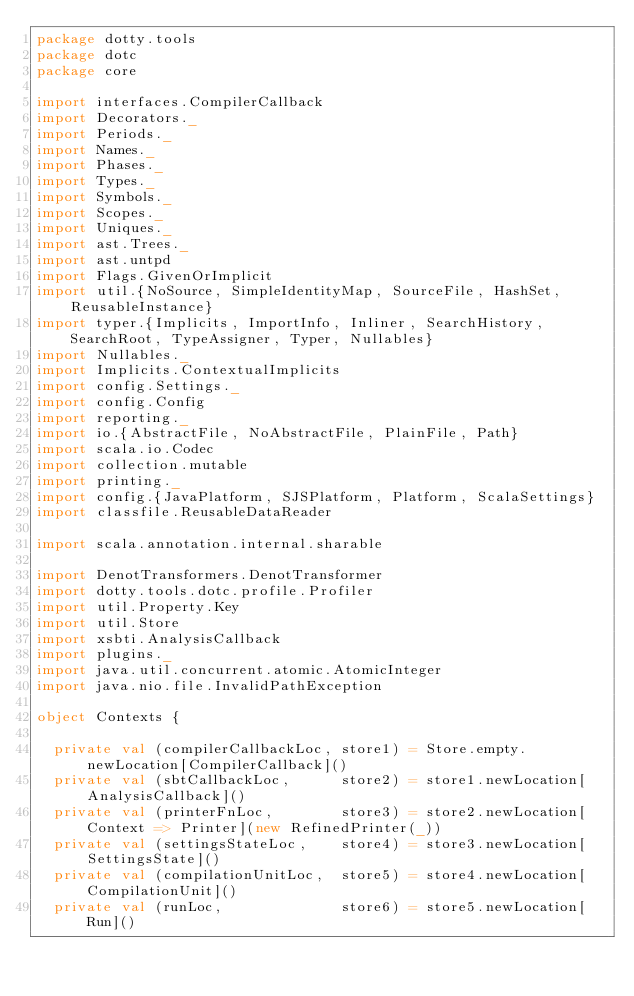Convert code to text. <code><loc_0><loc_0><loc_500><loc_500><_Scala_>package dotty.tools
package dotc
package core

import interfaces.CompilerCallback
import Decorators._
import Periods._
import Names._
import Phases._
import Types._
import Symbols._
import Scopes._
import Uniques._
import ast.Trees._
import ast.untpd
import Flags.GivenOrImplicit
import util.{NoSource, SimpleIdentityMap, SourceFile, HashSet, ReusableInstance}
import typer.{Implicits, ImportInfo, Inliner, SearchHistory, SearchRoot, TypeAssigner, Typer, Nullables}
import Nullables._
import Implicits.ContextualImplicits
import config.Settings._
import config.Config
import reporting._
import io.{AbstractFile, NoAbstractFile, PlainFile, Path}
import scala.io.Codec
import collection.mutable
import printing._
import config.{JavaPlatform, SJSPlatform, Platform, ScalaSettings}
import classfile.ReusableDataReader

import scala.annotation.internal.sharable

import DenotTransformers.DenotTransformer
import dotty.tools.dotc.profile.Profiler
import util.Property.Key
import util.Store
import xsbti.AnalysisCallback
import plugins._
import java.util.concurrent.atomic.AtomicInteger
import java.nio.file.InvalidPathException

object Contexts {

  private val (compilerCallbackLoc, store1) = Store.empty.newLocation[CompilerCallback]()
  private val (sbtCallbackLoc,      store2) = store1.newLocation[AnalysisCallback]()
  private val (printerFnLoc,        store3) = store2.newLocation[Context => Printer](new RefinedPrinter(_))
  private val (settingsStateLoc,    store4) = store3.newLocation[SettingsState]()
  private val (compilationUnitLoc,  store5) = store4.newLocation[CompilationUnit]()
  private val (runLoc,              store6) = store5.newLocation[Run]()</code> 